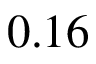<formula> <loc_0><loc_0><loc_500><loc_500>0 . 1 6</formula> 